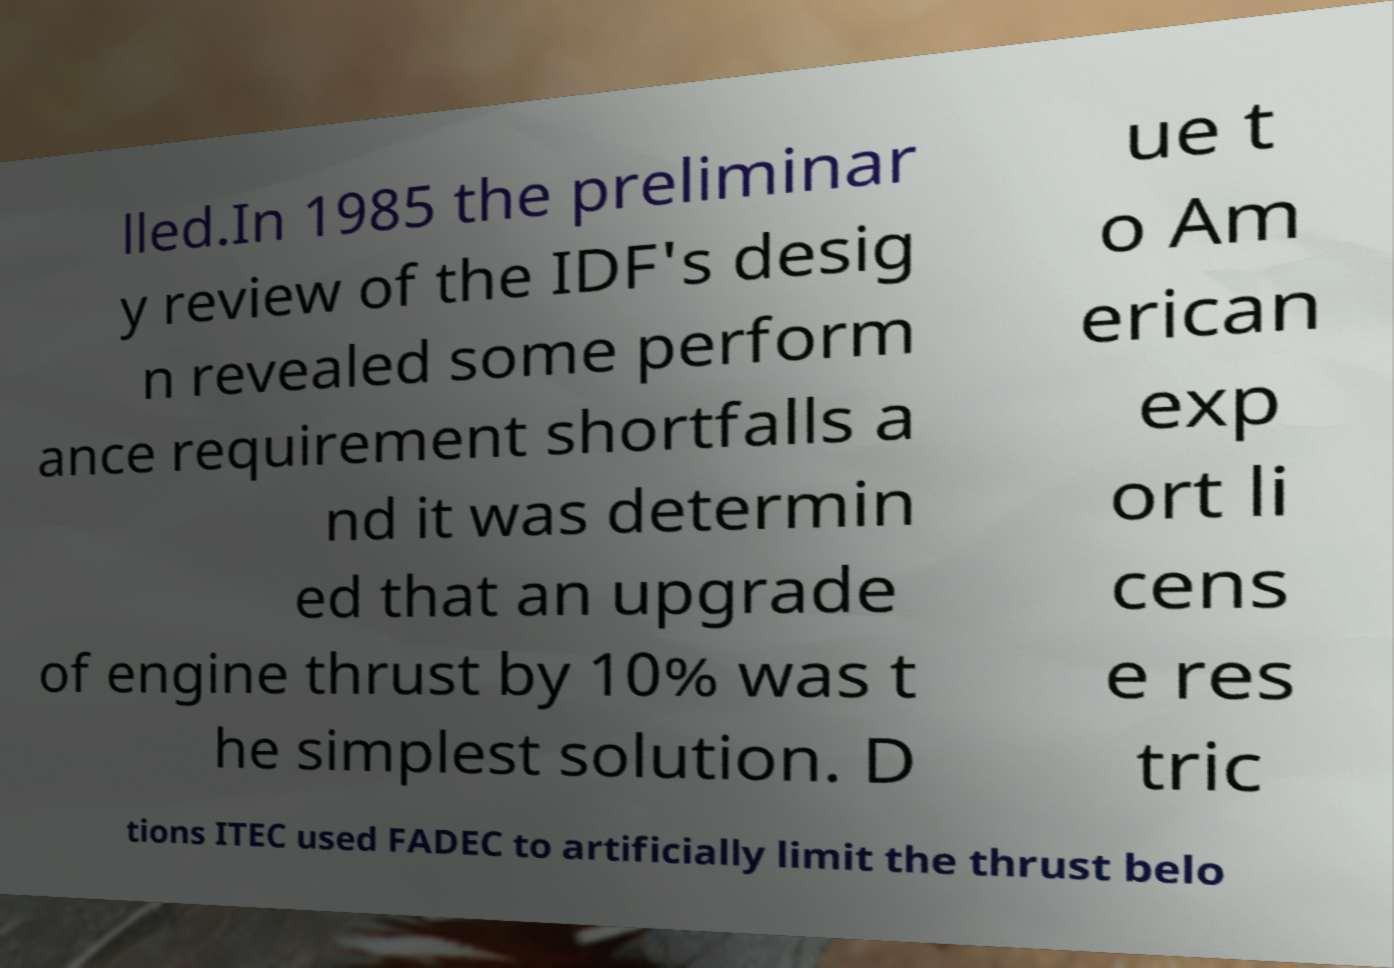What messages or text are displayed in this image? I need them in a readable, typed format. lled.In 1985 the preliminar y review of the IDF's desig n revealed some perform ance requirement shortfalls a nd it was determin ed that an upgrade of engine thrust by 10% was t he simplest solution. D ue t o Am erican exp ort li cens e res tric tions ITEC used FADEC to artificially limit the thrust belo 